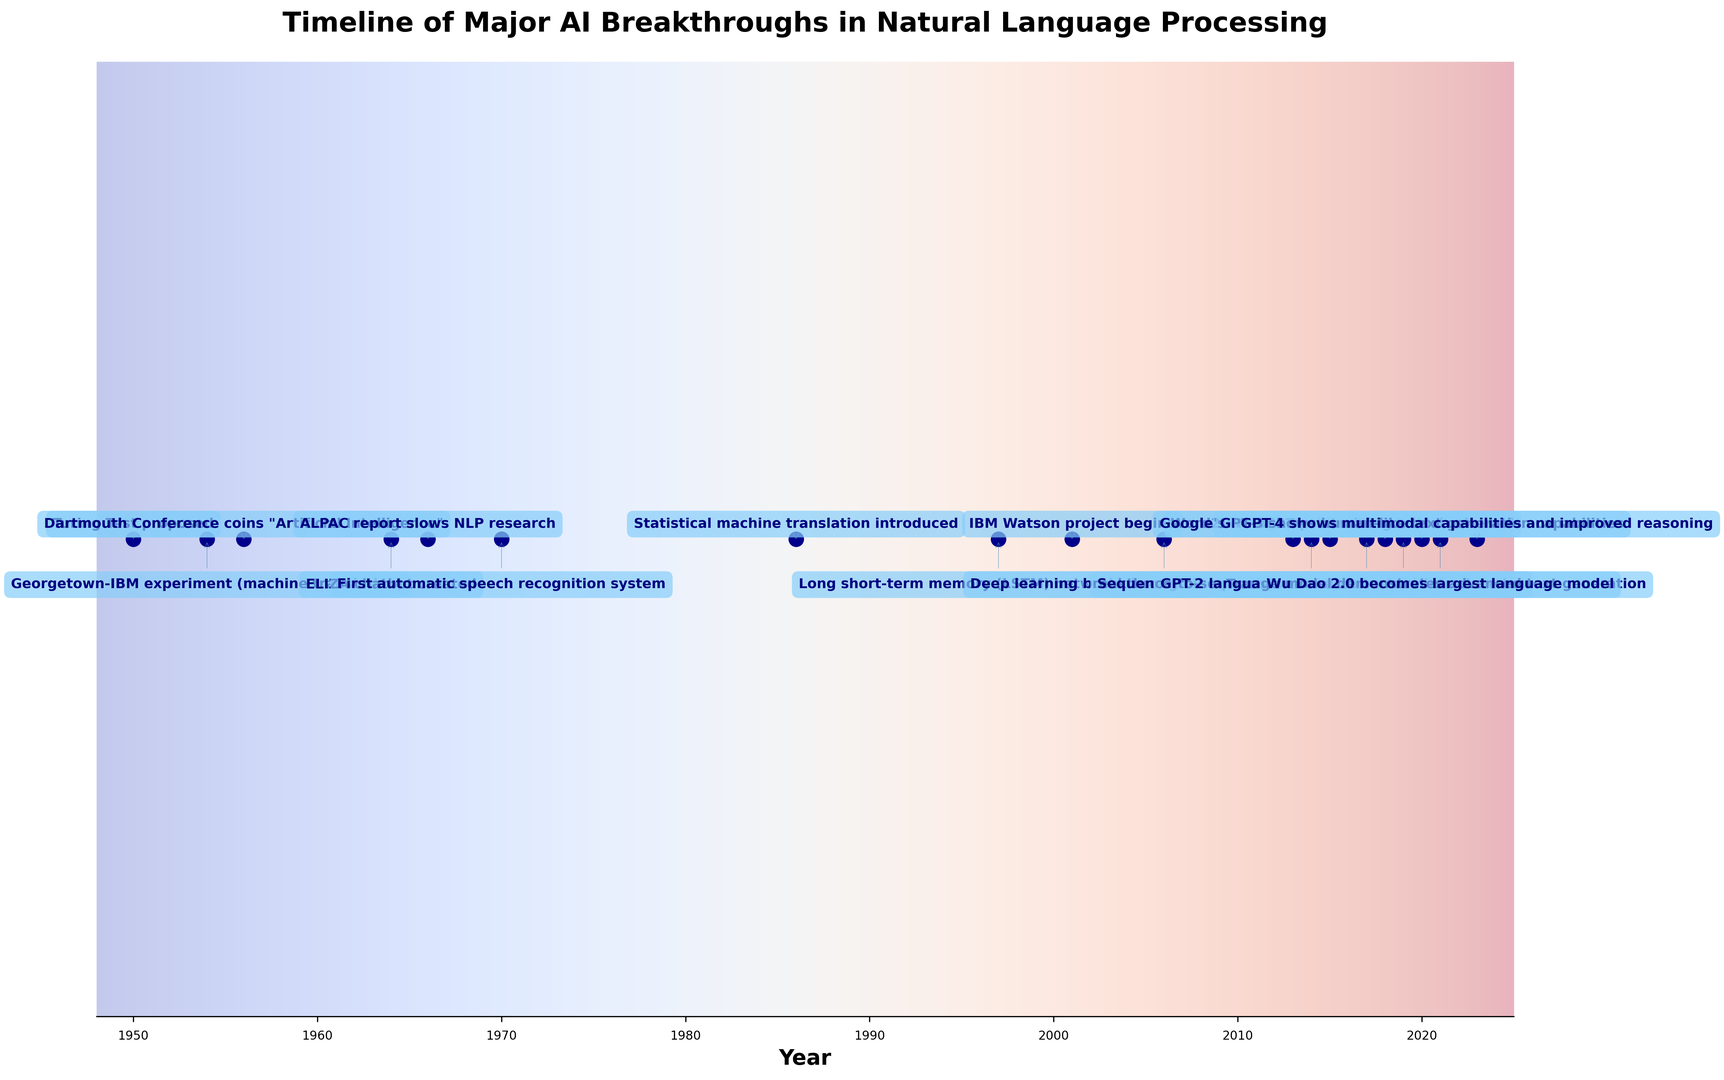When was the Turing Test proposed in relation to the Dartmouth Conference? The Turing Test was proposed in 1950 and the Dartmouth Conference coined the term "Artificial Intelligence" in 1956. Thus, the Turing Test was proposed 6 years before the Dartmouth Conference.
Answer: 6 years before What event marked the introduction of statistical machine translation? By examining the timeline, the event stating "Statistical machine translation introduced" happened in 1986, which marked the introduction of statistical machine translation.
Answer: 1986 How many years after the invention of LSTM networks was the Word2Vec algorithm introduced? LSTM networks were invented in 1997 and the Word2Vec algorithm was introduced in 2013. Therefore, the time between these two events is 2013 - 1997 = 16 years.
Answer: 16 years Which happened first: the creation of the ELIZA chatbot or the start of the IBM Watson project? Examining the timeline, the ELIZA chatbot was created in 1964, and the IBM Watson project began in 2001. Thus, the creation of the ELIZA chatbot happened well before the start of the IBM Watson project.
Answer: ELIZA chatbot creation How many major AI breakthroughs in natural language processing occurred between the introduction of the Transformer architecture and the release of GPT-3? The Transformer architecture was introduced in 2017, and GPT-3 showed human-like text generation capabilities in 2020. In this period, the BERT pre-training model was released in 2018 and GPT-2 demonstrated advanced text generation in 2019. So, there are 2 major breakthroughs between these events.
Answer: 2 Which event occurred closest to the year 2000: the introduction of statistical machine translation or the creation of the first automatic speech recognition system? Statistical machine translation was introduced in 1986 and the first automatic speech recognition system was created in 1970. The years 1986 and 1970 are 14 years and 30 years away from 2000 respectively. So, the introduction of statistical machine translation in 1986 happened closer to the year 2000.
Answer: Statistical machine translation introduction What were the two most recent major breakthroughs according to the timeline? Referring to the timeline, the two most recent breakthroughs are "GPT-4 shows multimodal capabilities and improved reasoning" in 2023 and "Wu Dao 2.0 becomes largest language model" in 2021.
Answer: GPT-4 and Wu Dao 2.0 How long after the ALPAC report did the deep learning breakthrough in speech recognition occur? The ALPAC report, which slowed NLP research, was published in 1966. The deep learning breakthrough in speech recognition occurred in 2006. Calculating the difference, 2006 - 1966 = 40 years.
Answer: 40 years 